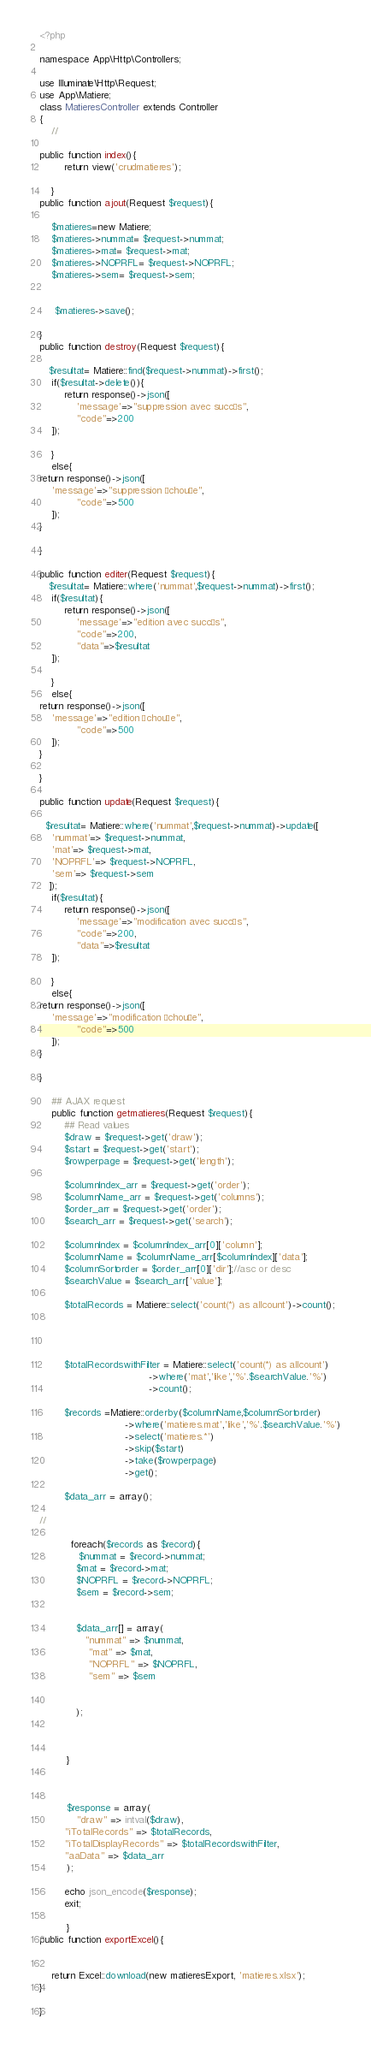<code> <loc_0><loc_0><loc_500><loc_500><_PHP_><?php

namespace App\Http\Controllers;

use Illuminate\Http\Request;
use App\Matiere;
class MatieresController extends Controller
{
    //

public function index(){
        return view('crudmatieres');

    }
public function ajout(Request $request){
    
    $matieres=new Matiere;
    $matieres->nummat= $request->nummat;
    $matieres->mat= $request->mat;
    $matieres->NOPRFL= $request->NOPRFL;
    $matieres->sem= $request->sem;
  
    
     $matieres->save();
   
}
public function destroy(Request $request){
     
   $resultat= Matiere::find($request->nummat)->first();
    if($resultat->delete()){
        return response()->json([
            'message'=>"suppression avec succès",
            "code"=>200
    ]);

    }
    else{
return response()->json([
    'message'=>"suppression échouée",
            "code"=>500
    ]);
}

}

public function editer(Request $request){
   $resultat= Matiere::where('nummat',$request->nummat)->first();
    if($resultat){
        return response()->json([
            'message'=>"edition avec succès",
            "code"=>200,
            "data"=>$resultat
    ]);

    }
    else{
return response()->json([
    'message'=>"edition échouée",
            "code"=>500
    ]);
}

}

public function update(Request $request){
    
  $resultat= Matiere::where('nummat',$request->nummat)->update([
    'nummat'=> $request->nummat,
    'mat'=> $request->mat,
    'NOPRFL'=> $request->NOPRFL,
    'sem'=> $request->sem
   ]);
    if($resultat){
        return response()->json([
            'message'=>"modification avec succès",
            "code"=>200,
            "data"=>$resultat
    ]);

    }
    else{
return response()->json([
    'message'=>"modification échouée",
            "code"=>500
    ]);
}

}

    ## AJAX request
    public function getmatieres(Request $request){
        ## Read values
        $draw = $request->get('draw');
        $start = $request->get('start');
        $rowperpage = $request->get('length'); 

        $columnIndex_arr = $request->get('order'); 
        $columnName_arr = $request->get('columns'); 
        $order_arr = $request->get('order'); 
        $search_arr = $request->get('search'); 

        $columnIndex = $columnIndex_arr[0]['column'];
        $columnName = $columnName_arr[$columnIndex]['data'];
        $columnSortorder = $order_arr[0]['dir'];//asc or desc
        $searchValue = $search_arr['value'];

        $totalRecords = Matiere::select('count(*) as allcount')->count();


        

        $totalRecordswithFilter = Matiere::select('count(*) as allcount')
                                    ->where('mat','like','%'.$searchValue.'%')
                                    ->count();

        $records =Matiere::orderby($columnName,$columnSortorder)   
                            ->where('matieres.mat','like','%'.$searchValue.'%')
                            ->select('matieres.*')
                            ->skip($start)
                            ->take($rowperpage)
                            ->get();

        $data_arr = array();

//
    
          foreach($records as $record){
             $nummat = $record->nummat;
            $mat = $record->mat;
            $NOPRFL = $record->NOPRFL;
            $sem = $record->sem;
           
          
            $data_arr[] = array(
               "nummat" => $nummat,
                "mat" => $mat,
                "NOPRFL" => $NOPRFL,
                "sem" => $sem
                
              
            );
            


         }

             

         $response = array(
            "draw" => intval($draw),
        "iTotalRecords" => $totalRecords,
        "iTotalDisplayRecords" => $totalRecordswithFilter,
        "aaData" => $data_arr
         );

        echo json_encode($response);
        exit;

         }
public function exportExcel(){


    return Excel::download(new matieresExport, 'matieres.xlsx');
} 

}
</code> 